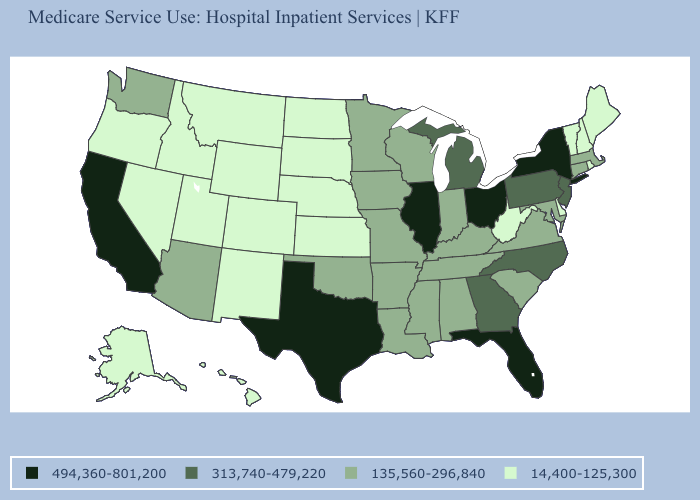What is the value of Indiana?
Quick response, please. 135,560-296,840. What is the highest value in states that border Kentucky?
Write a very short answer. 494,360-801,200. Is the legend a continuous bar?
Quick response, please. No. What is the value of North Dakota?
Write a very short answer. 14,400-125,300. Name the states that have a value in the range 494,360-801,200?
Give a very brief answer. California, Florida, Illinois, New York, Ohio, Texas. Name the states that have a value in the range 494,360-801,200?
Write a very short answer. California, Florida, Illinois, New York, Ohio, Texas. Does West Virginia have the highest value in the USA?
Short answer required. No. What is the highest value in the MidWest ?
Concise answer only. 494,360-801,200. What is the value of Connecticut?
Give a very brief answer. 135,560-296,840. Among the states that border Virginia , which have the highest value?
Write a very short answer. North Carolina. What is the value of West Virginia?
Answer briefly. 14,400-125,300. How many symbols are there in the legend?
Answer briefly. 4. Does the map have missing data?
Short answer required. No. Which states hav the highest value in the MidWest?
Give a very brief answer. Illinois, Ohio. 